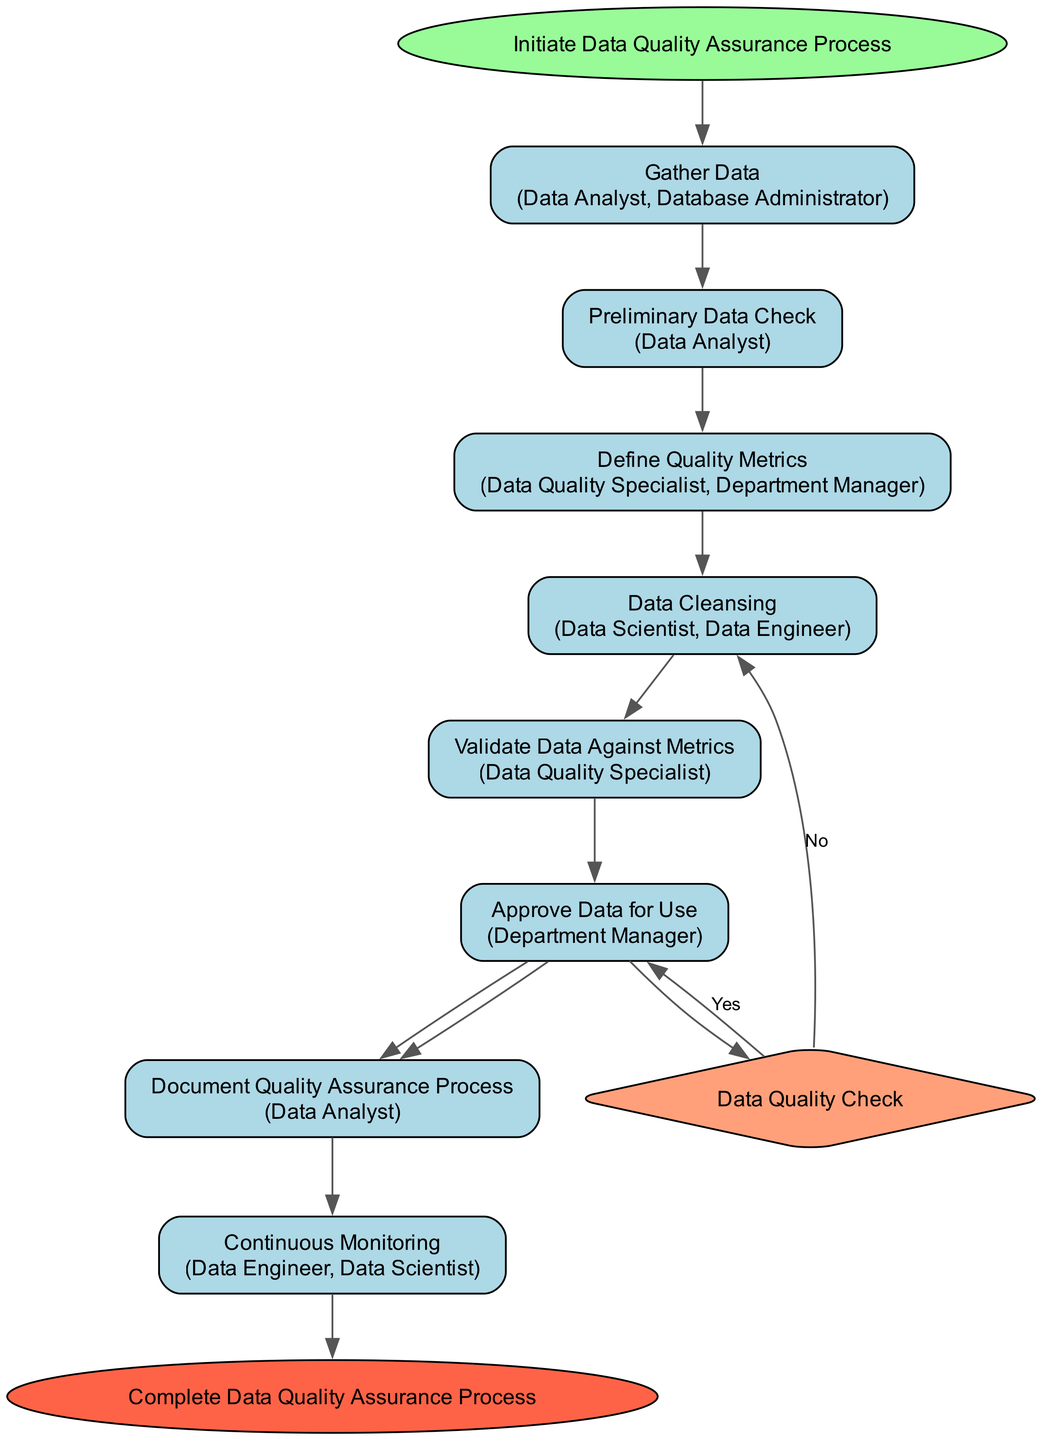What is the first activity in the diagram? The first activity is "Gather Data". It is listed first among the activities, and it follows the initial start node.
Answer: Gather Data Who is responsible for the "Data Cleansing" activity? The "Data Cleansing" activity involves the "Data Scientist" and "Data Engineer" as the actors responsible for this activity.
Answer: Data Scientist, Data Engineer How many activities are there in total? The total number of activities in the diagram is eight, as listed under the activities section.
Answer: 8 What decision is made regarding the "Data Quality Check"? The decision asks whether the data meets the required quality standards; if yes, it leads to "Approve Data for Use" and if no, it leads back to "Data Cleansing".
Answer: Approve Data for Use What happens if data quality metrics are not met? If the data quality metrics are not met, the process flows to "Data Cleansing" to rectify issues before further checks are made.
Answer: Data Cleansing Which actors are involved in defining quality metrics? The actors involved in defining quality metrics are the "Data Quality Specialist" and the "Department Manager". This is specified in the definitions of the activities.
Answer: Data Quality Specialist, Department Manager What is the final activity before the process ends? The final activity before the process ends is "Document Quality Assurance Process", which comes just before the end node in the flow.
Answer: Document Quality Assurance Process How many nodes represent decisions in the diagram? There is one decision node in the diagram, which pertains to the "Data Quality Check".
Answer: 1 What does the "Continuous Monitoring" activity entail? The "Continuous Monitoring" activity involves setting up processes for ongoing monitoring of data quality, as detailed under its description.
Answer: Set up processes for ongoing monitoring of data quality 